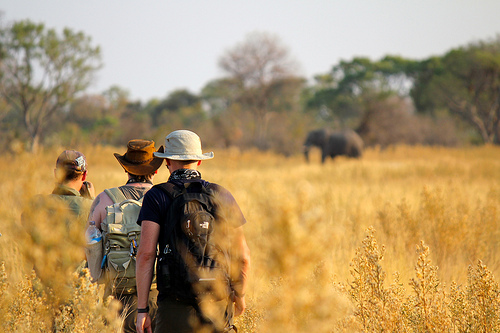If these men were to encounter a thunderstorm, how could their situation change? Encountering a thunderstorm would drastically change their situation. The once clear plains would turn treacherous, with strong winds and lightning presenting a serious hazard. They would have to find immediate shelter to protect themselves from the storm, potentially using the trees or makeshift coverings if they do not have tents. The rain would make the ground slippery and muddy, slowing down their movement and making it harder to carry their equipment. Communication devices might get waterlogged, causing them to lose contact with their base. Their priority would shift from observing wildlife to ensuring their own safety until the storm passes. 